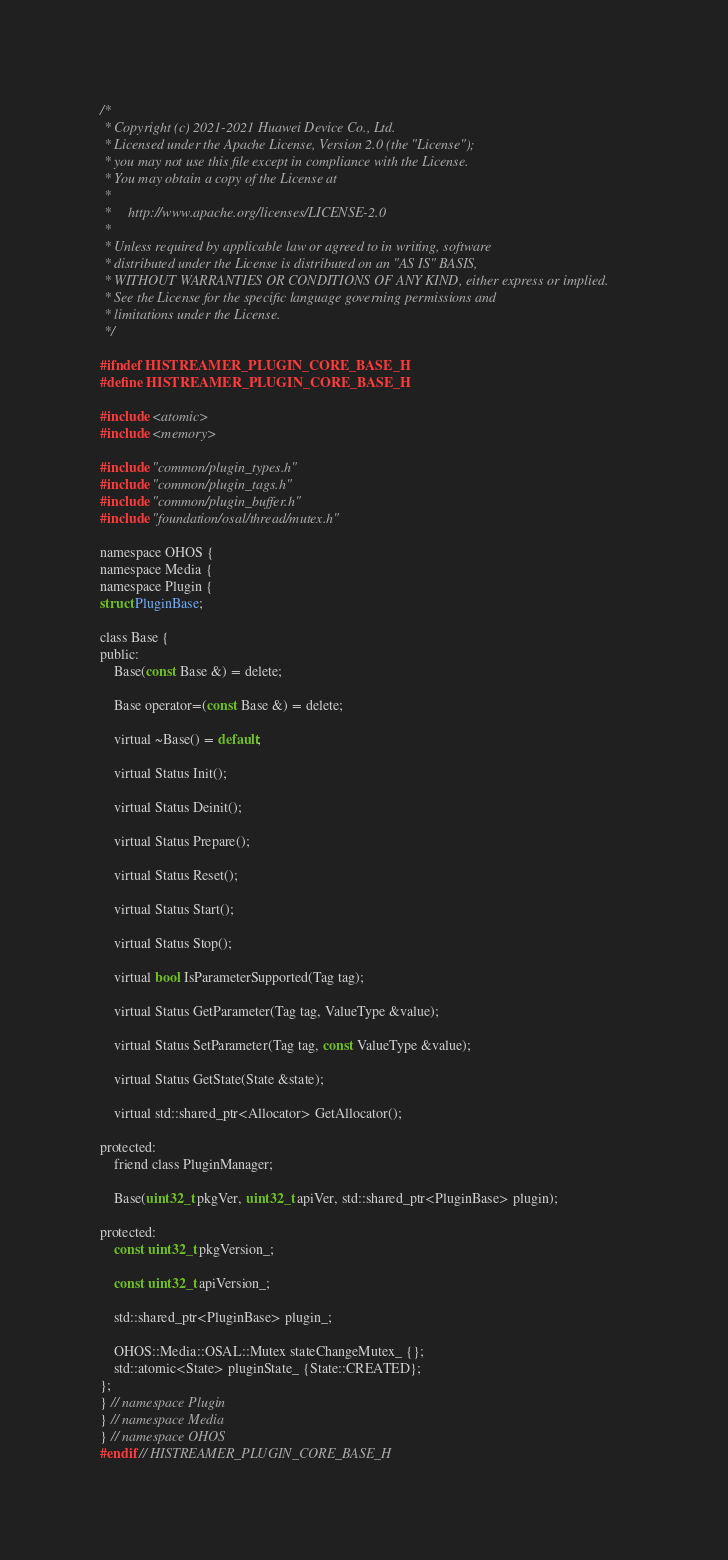<code> <loc_0><loc_0><loc_500><loc_500><_C_>/*
 * Copyright (c) 2021-2021 Huawei Device Co., Ltd.
 * Licensed under the Apache License, Version 2.0 (the "License");
 * you may not use this file except in compliance with the License.
 * You may obtain a copy of the License at
 *
 *     http://www.apache.org/licenses/LICENSE-2.0
 *
 * Unless required by applicable law or agreed to in writing, software
 * distributed under the License is distributed on an "AS IS" BASIS,
 * WITHOUT WARRANTIES OR CONDITIONS OF ANY KIND, either express or implied.
 * See the License for the specific language governing permissions and
 * limitations under the License.
 */

#ifndef HISTREAMER_PLUGIN_CORE_BASE_H
#define HISTREAMER_PLUGIN_CORE_BASE_H

#include <atomic>
#include <memory>

#include "common/plugin_types.h"
#include "common/plugin_tags.h"
#include "common/plugin_buffer.h"
#include "foundation/osal/thread/mutex.h"

namespace OHOS {
namespace Media {
namespace Plugin {
struct PluginBase;

class Base {
public:
    Base(const Base &) = delete;

    Base operator=(const Base &) = delete;

    virtual ~Base() = default;

    virtual Status Init();

    virtual Status Deinit();

    virtual Status Prepare();

    virtual Status Reset();

    virtual Status Start();

    virtual Status Stop();

    virtual bool IsParameterSupported(Tag tag);

    virtual Status GetParameter(Tag tag, ValueType &value);

    virtual Status SetParameter(Tag tag, const ValueType &value);

    virtual Status GetState(State &state);

    virtual std::shared_ptr<Allocator> GetAllocator();

protected:
    friend class PluginManager;

    Base(uint32_t pkgVer, uint32_t apiVer, std::shared_ptr<PluginBase> plugin);

protected:
    const uint32_t pkgVersion_;

    const uint32_t apiVersion_;

    std::shared_ptr<PluginBase> plugin_;

    OHOS::Media::OSAL::Mutex stateChangeMutex_ {};
    std::atomic<State> pluginState_ {State::CREATED};
};
} // namespace Plugin
} // namespace Media
} // namespace OHOS
#endif // HISTREAMER_PLUGIN_CORE_BASE_H
</code> 